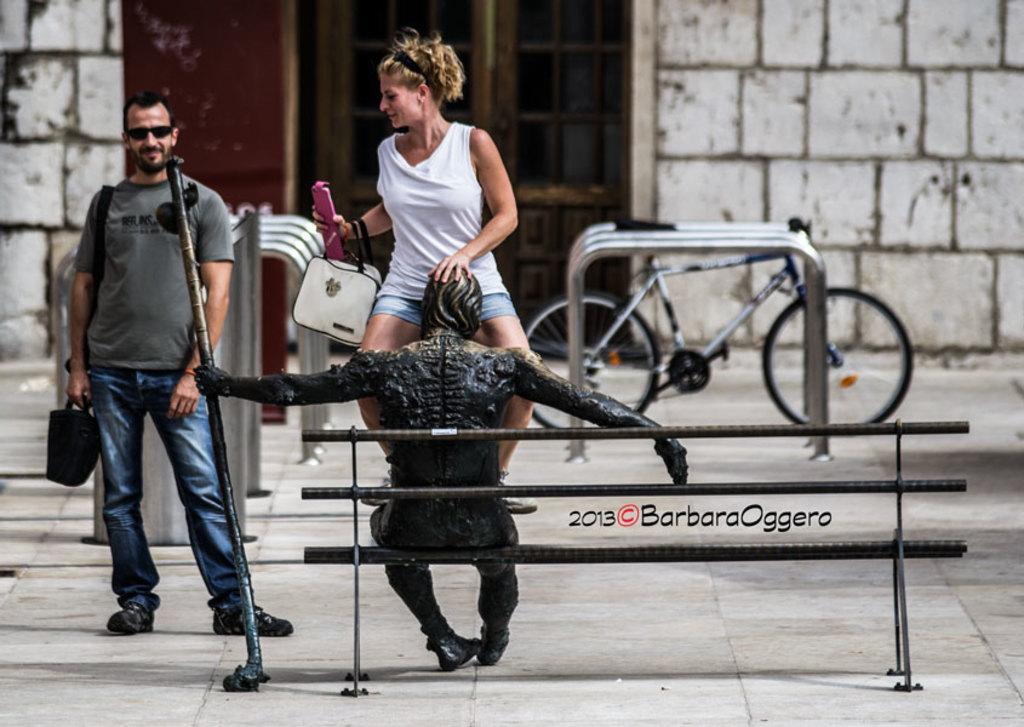How would you summarize this image in a sentence or two? There is a woman who is trying to sit on a statue which is on the table. There is another man who is standing on the left side and staring at this woman. There is a bicycle parked at the right side. 